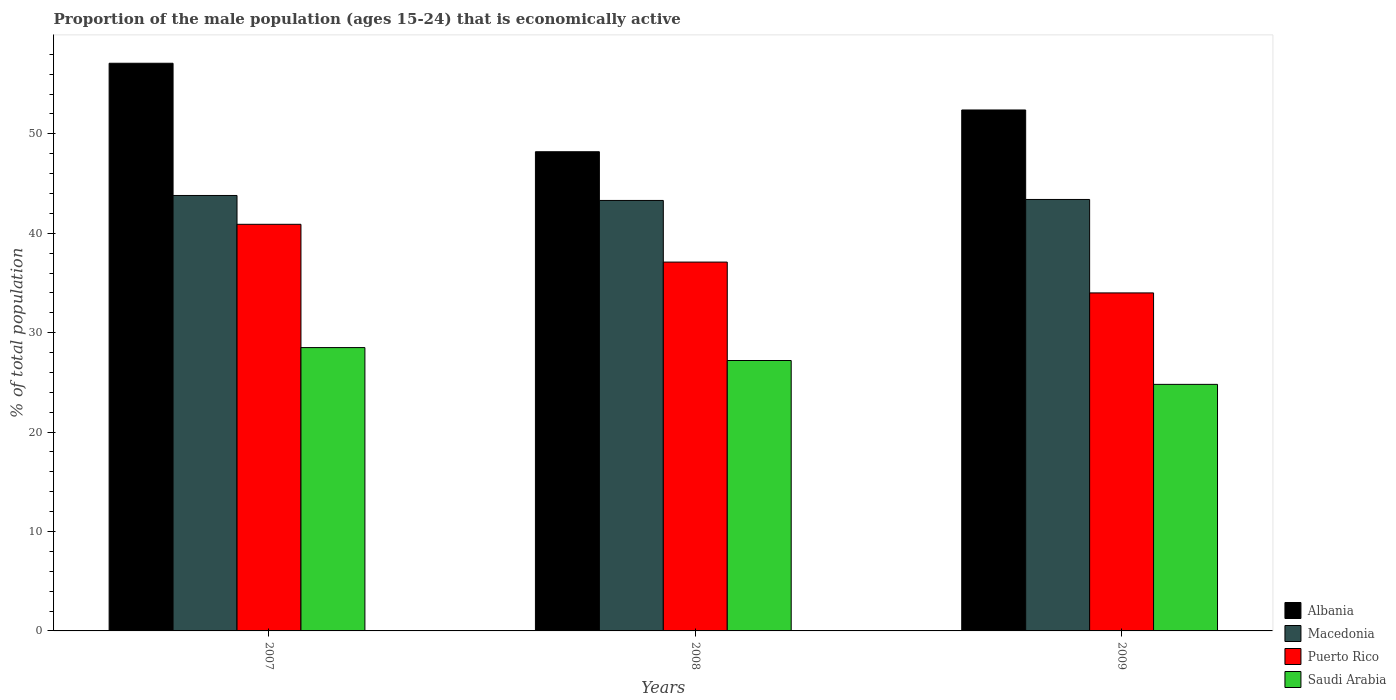Are the number of bars per tick equal to the number of legend labels?
Keep it short and to the point. Yes. Are the number of bars on each tick of the X-axis equal?
Your answer should be compact. Yes. What is the proportion of the male population that is economically active in Macedonia in 2008?
Offer a very short reply. 43.3. Across all years, what is the maximum proportion of the male population that is economically active in Macedonia?
Offer a terse response. 43.8. Across all years, what is the minimum proportion of the male population that is economically active in Macedonia?
Make the answer very short. 43.3. In which year was the proportion of the male population that is economically active in Saudi Arabia maximum?
Your response must be concise. 2007. What is the total proportion of the male population that is economically active in Albania in the graph?
Provide a short and direct response. 157.7. What is the difference between the proportion of the male population that is economically active in Albania in 2007 and that in 2009?
Offer a very short reply. 4.7. What is the difference between the proportion of the male population that is economically active in Puerto Rico in 2008 and the proportion of the male population that is economically active in Albania in 2009?
Provide a short and direct response. -15.3. What is the average proportion of the male population that is economically active in Puerto Rico per year?
Give a very brief answer. 37.33. In how many years, is the proportion of the male population that is economically active in Puerto Rico greater than 30 %?
Make the answer very short. 3. What is the ratio of the proportion of the male population that is economically active in Puerto Rico in 2007 to that in 2009?
Your answer should be compact. 1.2. Is the proportion of the male population that is economically active in Saudi Arabia in 2007 less than that in 2008?
Provide a succinct answer. No. Is the difference between the proportion of the male population that is economically active in Albania in 2007 and 2009 greater than the difference between the proportion of the male population that is economically active in Macedonia in 2007 and 2009?
Keep it short and to the point. Yes. What is the difference between the highest and the second highest proportion of the male population that is economically active in Saudi Arabia?
Give a very brief answer. 1.3. What is the difference between the highest and the lowest proportion of the male population that is economically active in Albania?
Keep it short and to the point. 8.9. In how many years, is the proportion of the male population that is economically active in Macedonia greater than the average proportion of the male population that is economically active in Macedonia taken over all years?
Your answer should be very brief. 1. Is the sum of the proportion of the male population that is economically active in Puerto Rico in 2007 and 2009 greater than the maximum proportion of the male population that is economically active in Macedonia across all years?
Provide a short and direct response. Yes. What does the 4th bar from the left in 2007 represents?
Provide a short and direct response. Saudi Arabia. What does the 4th bar from the right in 2009 represents?
Your answer should be very brief. Albania. How many bars are there?
Provide a short and direct response. 12. How many years are there in the graph?
Your answer should be very brief. 3. Does the graph contain grids?
Your answer should be compact. No. Where does the legend appear in the graph?
Your answer should be compact. Bottom right. How many legend labels are there?
Your response must be concise. 4. What is the title of the graph?
Keep it short and to the point. Proportion of the male population (ages 15-24) that is economically active. What is the label or title of the Y-axis?
Offer a very short reply. % of total population. What is the % of total population of Albania in 2007?
Give a very brief answer. 57.1. What is the % of total population in Macedonia in 2007?
Make the answer very short. 43.8. What is the % of total population in Puerto Rico in 2007?
Keep it short and to the point. 40.9. What is the % of total population in Saudi Arabia in 2007?
Your response must be concise. 28.5. What is the % of total population of Albania in 2008?
Provide a short and direct response. 48.2. What is the % of total population of Macedonia in 2008?
Your response must be concise. 43.3. What is the % of total population of Puerto Rico in 2008?
Offer a terse response. 37.1. What is the % of total population of Saudi Arabia in 2008?
Offer a terse response. 27.2. What is the % of total population of Albania in 2009?
Provide a short and direct response. 52.4. What is the % of total population in Macedonia in 2009?
Give a very brief answer. 43.4. What is the % of total population in Puerto Rico in 2009?
Provide a short and direct response. 34. What is the % of total population in Saudi Arabia in 2009?
Ensure brevity in your answer.  24.8. Across all years, what is the maximum % of total population of Albania?
Offer a very short reply. 57.1. Across all years, what is the maximum % of total population of Macedonia?
Give a very brief answer. 43.8. Across all years, what is the maximum % of total population in Puerto Rico?
Your answer should be very brief. 40.9. Across all years, what is the minimum % of total population of Albania?
Provide a short and direct response. 48.2. Across all years, what is the minimum % of total population of Macedonia?
Provide a short and direct response. 43.3. Across all years, what is the minimum % of total population in Saudi Arabia?
Your answer should be compact. 24.8. What is the total % of total population of Albania in the graph?
Your answer should be compact. 157.7. What is the total % of total population in Macedonia in the graph?
Keep it short and to the point. 130.5. What is the total % of total population of Puerto Rico in the graph?
Make the answer very short. 112. What is the total % of total population of Saudi Arabia in the graph?
Make the answer very short. 80.5. What is the difference between the % of total population of Albania in 2007 and that in 2008?
Your answer should be very brief. 8.9. What is the difference between the % of total population of Macedonia in 2007 and that in 2008?
Keep it short and to the point. 0.5. What is the difference between the % of total population in Saudi Arabia in 2007 and that in 2008?
Ensure brevity in your answer.  1.3. What is the difference between the % of total population in Puerto Rico in 2007 and that in 2009?
Your answer should be compact. 6.9. What is the difference between the % of total population in Saudi Arabia in 2007 and that in 2009?
Offer a terse response. 3.7. What is the difference between the % of total population in Albania in 2008 and that in 2009?
Offer a very short reply. -4.2. What is the difference between the % of total population of Macedonia in 2008 and that in 2009?
Keep it short and to the point. -0.1. What is the difference between the % of total population of Saudi Arabia in 2008 and that in 2009?
Your response must be concise. 2.4. What is the difference between the % of total population in Albania in 2007 and the % of total population in Saudi Arabia in 2008?
Provide a short and direct response. 29.9. What is the difference between the % of total population of Puerto Rico in 2007 and the % of total population of Saudi Arabia in 2008?
Your answer should be compact. 13.7. What is the difference between the % of total population of Albania in 2007 and the % of total population of Macedonia in 2009?
Ensure brevity in your answer.  13.7. What is the difference between the % of total population in Albania in 2007 and the % of total population in Puerto Rico in 2009?
Your answer should be very brief. 23.1. What is the difference between the % of total population in Albania in 2007 and the % of total population in Saudi Arabia in 2009?
Offer a very short reply. 32.3. What is the difference between the % of total population in Macedonia in 2007 and the % of total population in Puerto Rico in 2009?
Your answer should be compact. 9.8. What is the difference between the % of total population of Macedonia in 2007 and the % of total population of Saudi Arabia in 2009?
Your answer should be very brief. 19. What is the difference between the % of total population in Puerto Rico in 2007 and the % of total population in Saudi Arabia in 2009?
Keep it short and to the point. 16.1. What is the difference between the % of total population of Albania in 2008 and the % of total population of Macedonia in 2009?
Provide a succinct answer. 4.8. What is the difference between the % of total population of Albania in 2008 and the % of total population of Saudi Arabia in 2009?
Provide a succinct answer. 23.4. What is the difference between the % of total population in Macedonia in 2008 and the % of total population in Saudi Arabia in 2009?
Provide a succinct answer. 18.5. What is the average % of total population in Albania per year?
Keep it short and to the point. 52.57. What is the average % of total population in Macedonia per year?
Your answer should be compact. 43.5. What is the average % of total population in Puerto Rico per year?
Make the answer very short. 37.33. What is the average % of total population of Saudi Arabia per year?
Provide a short and direct response. 26.83. In the year 2007, what is the difference between the % of total population of Albania and % of total population of Macedonia?
Offer a terse response. 13.3. In the year 2007, what is the difference between the % of total population of Albania and % of total population of Puerto Rico?
Your answer should be very brief. 16.2. In the year 2007, what is the difference between the % of total population of Albania and % of total population of Saudi Arabia?
Ensure brevity in your answer.  28.6. In the year 2007, what is the difference between the % of total population in Macedonia and % of total population in Puerto Rico?
Provide a succinct answer. 2.9. In the year 2007, what is the difference between the % of total population in Puerto Rico and % of total population in Saudi Arabia?
Offer a very short reply. 12.4. In the year 2008, what is the difference between the % of total population in Albania and % of total population in Macedonia?
Your response must be concise. 4.9. In the year 2008, what is the difference between the % of total population of Albania and % of total population of Saudi Arabia?
Provide a succinct answer. 21. In the year 2008, what is the difference between the % of total population in Macedonia and % of total population in Puerto Rico?
Provide a short and direct response. 6.2. In the year 2008, what is the difference between the % of total population of Puerto Rico and % of total population of Saudi Arabia?
Offer a very short reply. 9.9. In the year 2009, what is the difference between the % of total population in Albania and % of total population in Macedonia?
Ensure brevity in your answer.  9. In the year 2009, what is the difference between the % of total population in Albania and % of total population in Saudi Arabia?
Provide a succinct answer. 27.6. In the year 2009, what is the difference between the % of total population in Macedonia and % of total population in Puerto Rico?
Your answer should be very brief. 9.4. In the year 2009, what is the difference between the % of total population of Macedonia and % of total population of Saudi Arabia?
Your response must be concise. 18.6. What is the ratio of the % of total population in Albania in 2007 to that in 2008?
Ensure brevity in your answer.  1.18. What is the ratio of the % of total population in Macedonia in 2007 to that in 2008?
Ensure brevity in your answer.  1.01. What is the ratio of the % of total population of Puerto Rico in 2007 to that in 2008?
Keep it short and to the point. 1.1. What is the ratio of the % of total population of Saudi Arabia in 2007 to that in 2008?
Give a very brief answer. 1.05. What is the ratio of the % of total population in Albania in 2007 to that in 2009?
Your answer should be compact. 1.09. What is the ratio of the % of total population in Macedonia in 2007 to that in 2009?
Offer a terse response. 1.01. What is the ratio of the % of total population of Puerto Rico in 2007 to that in 2009?
Your answer should be very brief. 1.2. What is the ratio of the % of total population of Saudi Arabia in 2007 to that in 2009?
Make the answer very short. 1.15. What is the ratio of the % of total population of Albania in 2008 to that in 2009?
Keep it short and to the point. 0.92. What is the ratio of the % of total population in Puerto Rico in 2008 to that in 2009?
Your answer should be compact. 1.09. What is the ratio of the % of total population of Saudi Arabia in 2008 to that in 2009?
Provide a short and direct response. 1.1. What is the difference between the highest and the second highest % of total population of Puerto Rico?
Offer a terse response. 3.8. What is the difference between the highest and the lowest % of total population of Albania?
Your answer should be compact. 8.9. What is the difference between the highest and the lowest % of total population of Puerto Rico?
Keep it short and to the point. 6.9. What is the difference between the highest and the lowest % of total population in Saudi Arabia?
Offer a very short reply. 3.7. 